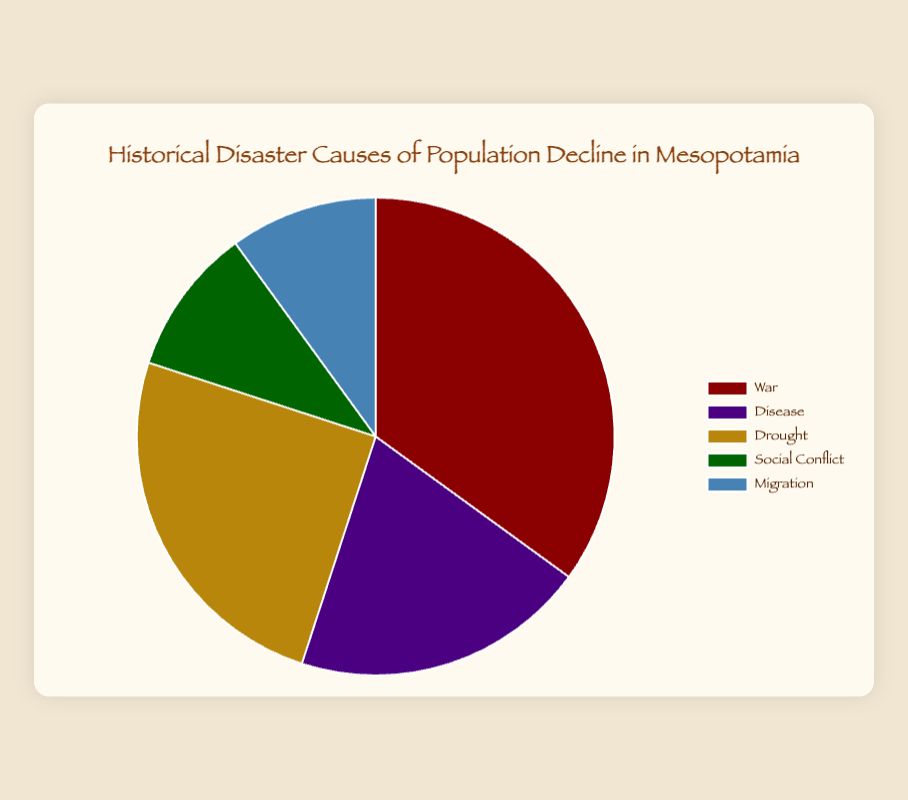What is the most common cause of population decline in Mesopotamia? The largest segment of the pie chart represents War, which indicates that it is the most common cause.
Answer: War Which cause of population decline has an equal percentage to Migration? The pie chart shows that both Social Conflict and Migration have the same percentage of the population decline, which is 10%.
Answer: Social Conflict What is the combined percentage of population decline due to Disease and Drought? The percentages for Disease and Drought are 20% and 25% respectively, so their combined percentage is 20% + 25% = 45%.
Answer: 45% Which cause of population decline has the smallest segment on the pie chart? Social Conflict and Migration both represent 10% each, making them the smallest segments visible on the chart.
Answer: Social Conflict and Migration How much greater is the percentage of population decline due to War compared to Disease? War accounts for 35% whereas Disease accounts for 20%, so the difference is 35% - 20% = 15%.
Answer: 15% Which causes together account for half of the total population decline? War accounts for 35% and Drought accounts for 25%. Adding these gives 35% + 25% = 60%, which is more than half. The next highest combination below 50% would be Disease (20%) and Drought (25%), totaling 45%. War and Social Conflict together account for just short of half at 45%. So, the smallest valid set adds up to Disease (20%) and Drought (25%).
Answer: Drought and Disease If you combine the causes with the smallest percentages, what fraction of the population decline do they represent together? Social Conflict and Migration both account for 10% each. So together, it is (10% + 10%) = 20%.
Answer: 20% Based on the pie chart, what is the likelihood that a random historical disaster causing population decline in Mesopotamia would be due to Disease or War? The probability is calculated by adding the percentages of Disease (20%) and War (35%), so 20% + 35% = 55%.
Answer: 55% Compare the decline percentages caused by Drought and Social Conflict. How much more significant is Drought? Drought causes 25% of the population decline, while Social Conflict accounts for 10%. The difference is 25% - 10% = 15%.
Answer: 15% What color represents the disaster with the highest percentage of population decline in the pie chart? The disaster with the highest percentage is War, represented by the color red.
Answer: Red 